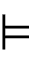<formula> <loc_0><loc_0><loc_500><loc_500>\vDash</formula> 